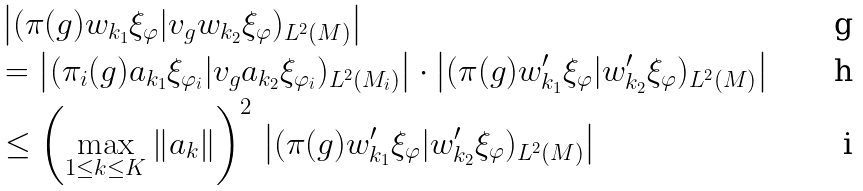<formula> <loc_0><loc_0><loc_500><loc_500>& \left | ( \pi ( g ) w _ { k _ { 1 } } \xi _ { \varphi } | v _ { g } w _ { k _ { 2 } } \xi _ { \varphi } ) _ { L ^ { 2 } ( M ) } \right | \\ & = \left | ( \pi _ { i } ( g ) a _ { k _ { 1 } } \xi _ { \varphi _ { i } } | v _ { g } a _ { k _ { 2 } } \xi _ { \varphi _ { i } } ) _ { L ^ { 2 } ( M _ { i } ) } \right | \cdot \left | ( \pi ( g ) w ^ { \prime } _ { k _ { 1 } } \xi _ { \varphi } | w ^ { \prime } _ { k _ { 2 } } \xi _ { \varphi } ) _ { L ^ { 2 } ( M ) } \right | \\ & \leq \left ( \max _ { 1 \leq k \leq K } \| a _ { k } \| \right ) ^ { 2 } \, \left | ( \pi ( g ) w ^ { \prime } _ { k _ { 1 } } \xi _ { \varphi } | w ^ { \prime } _ { k _ { 2 } } \xi _ { \varphi } ) _ { L ^ { 2 } ( M ) } \right |</formula> 